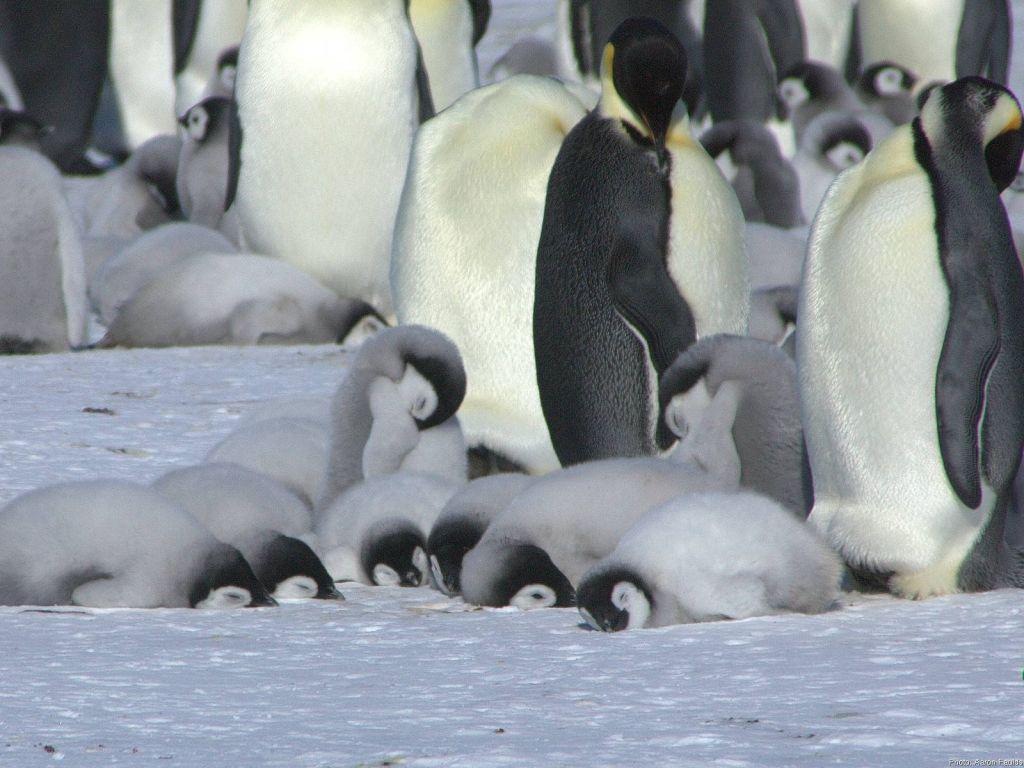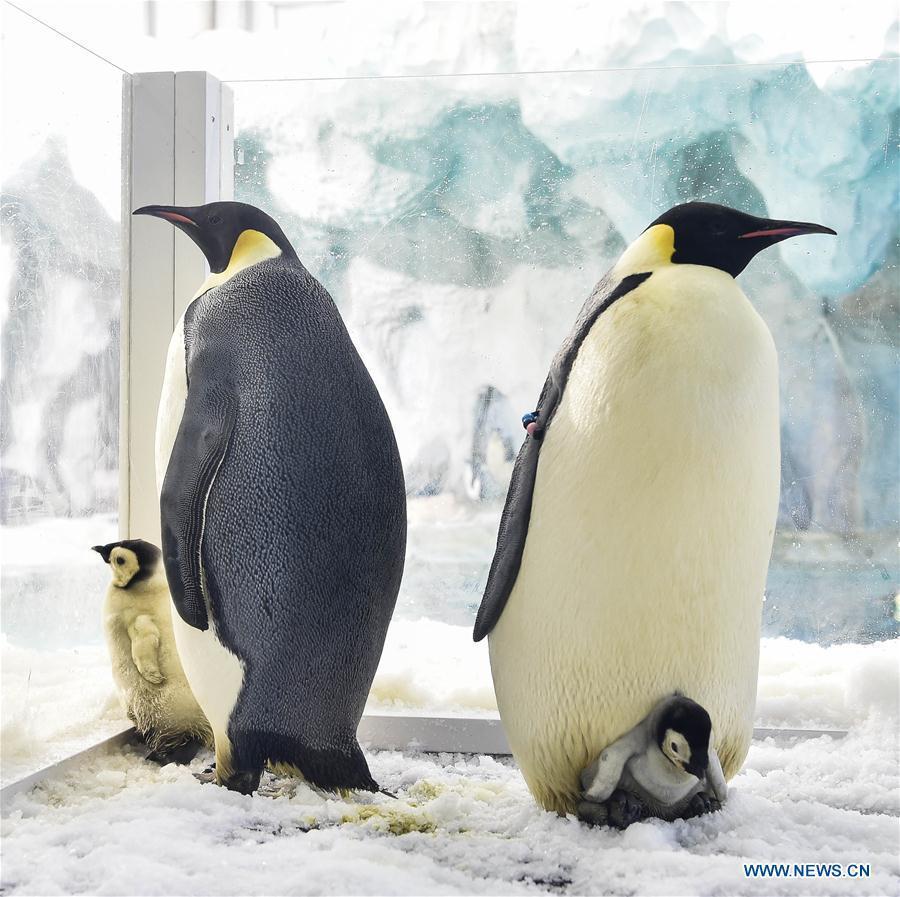The first image is the image on the left, the second image is the image on the right. Given the left and right images, does the statement "In one image of each pait a baby penguin has its mouth wide open." hold true? Answer yes or no. No. The first image is the image on the left, the second image is the image on the right. Examine the images to the left and right. Is the description "A baby penguin is standing near its mother with its mouth open." accurate? Answer yes or no. No. 